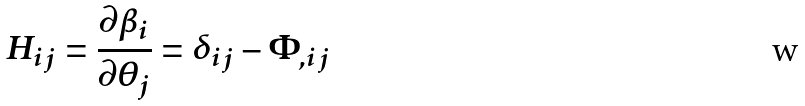<formula> <loc_0><loc_0><loc_500><loc_500>H _ { i j } = \frac { \partial \beta _ { i } } { \partial \theta _ { j } } = \delta _ { i j } - \Phi _ { , i j }</formula> 